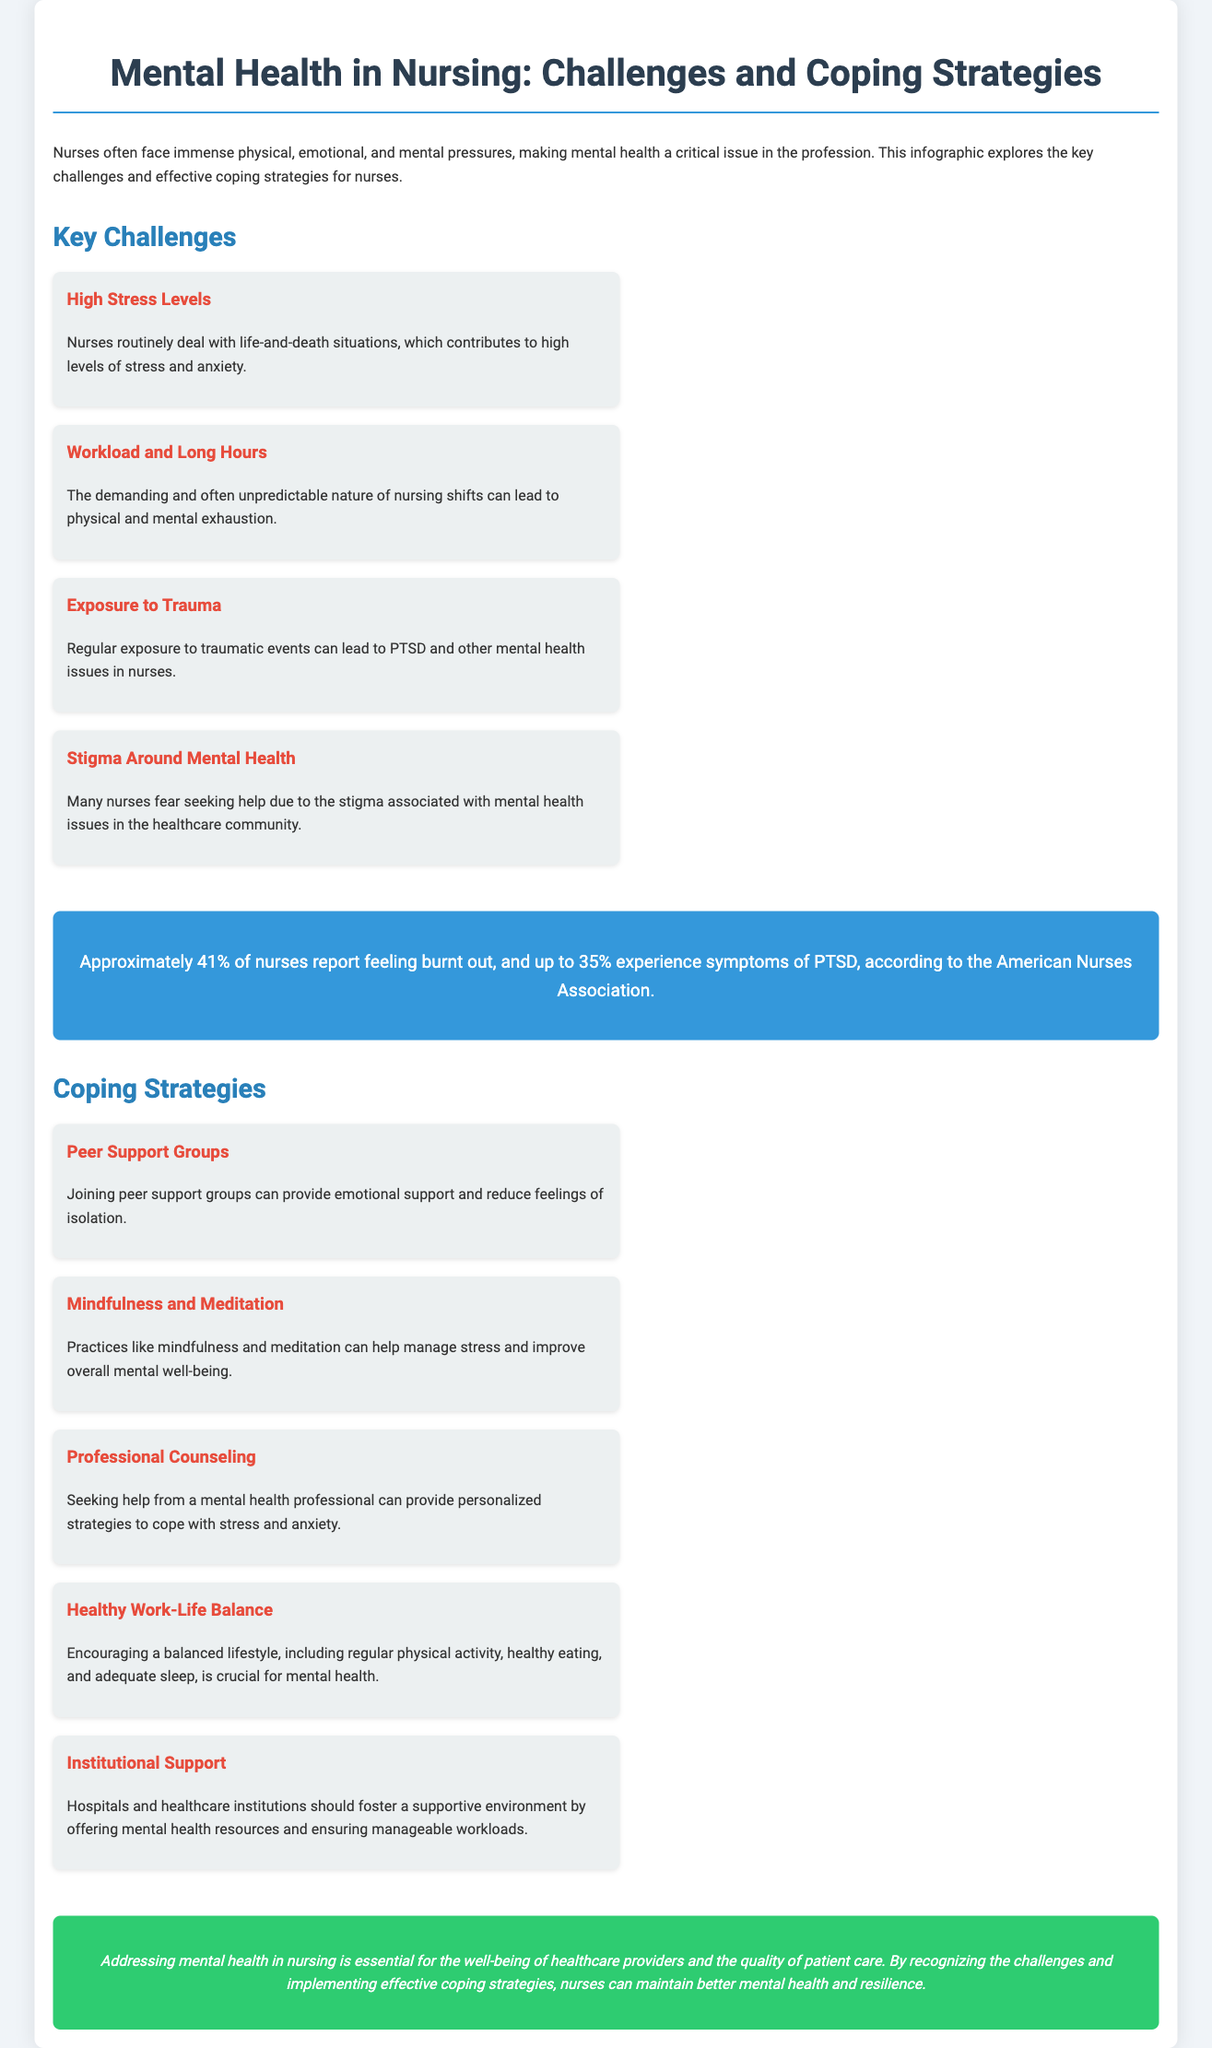what percentage of nurses report feeling burnt out? The document states that approximately 41% of nurses report feeling burnt out.
Answer: 41% what is a coping strategy mentioned for managing stress? One of the coping strategies mentioned is "Mindfulness and Meditation."
Answer: Mindfulness and Meditation name a key challenge faced by nurses. One of the key challenges listed is "Exposure to Trauma."
Answer: Exposure to Trauma how many strategies for coping with mental health issues are listed? The document lists five coping strategies for addressing mental health issues.
Answer: five what is the significance of addressing mental health in nursing? The conclusion emphasizes that addressing mental health is essential for the well-being of healthcare providers and the quality of patient care.
Answer: well-being of healthcare providers which organization provided the statistics mentioned in the document? The statistics regarding burnout and PTSD are attributed to the "American Nurses Association."
Answer: American Nurses Association what color is used for the title background in the document? The title background has a color of #3498db, which is a shade of blue.
Answer: blue what type of support can help reduce feelings of isolation? "Peer Support Groups" can help reduce feelings of isolation among nurses.
Answer: Peer Support Groups how does the document suggest institutional support can be fostered? The document suggests that hospitals should offer mental health resources and ensure manageable workloads to foster institutional support.
Answer: mental health resources 